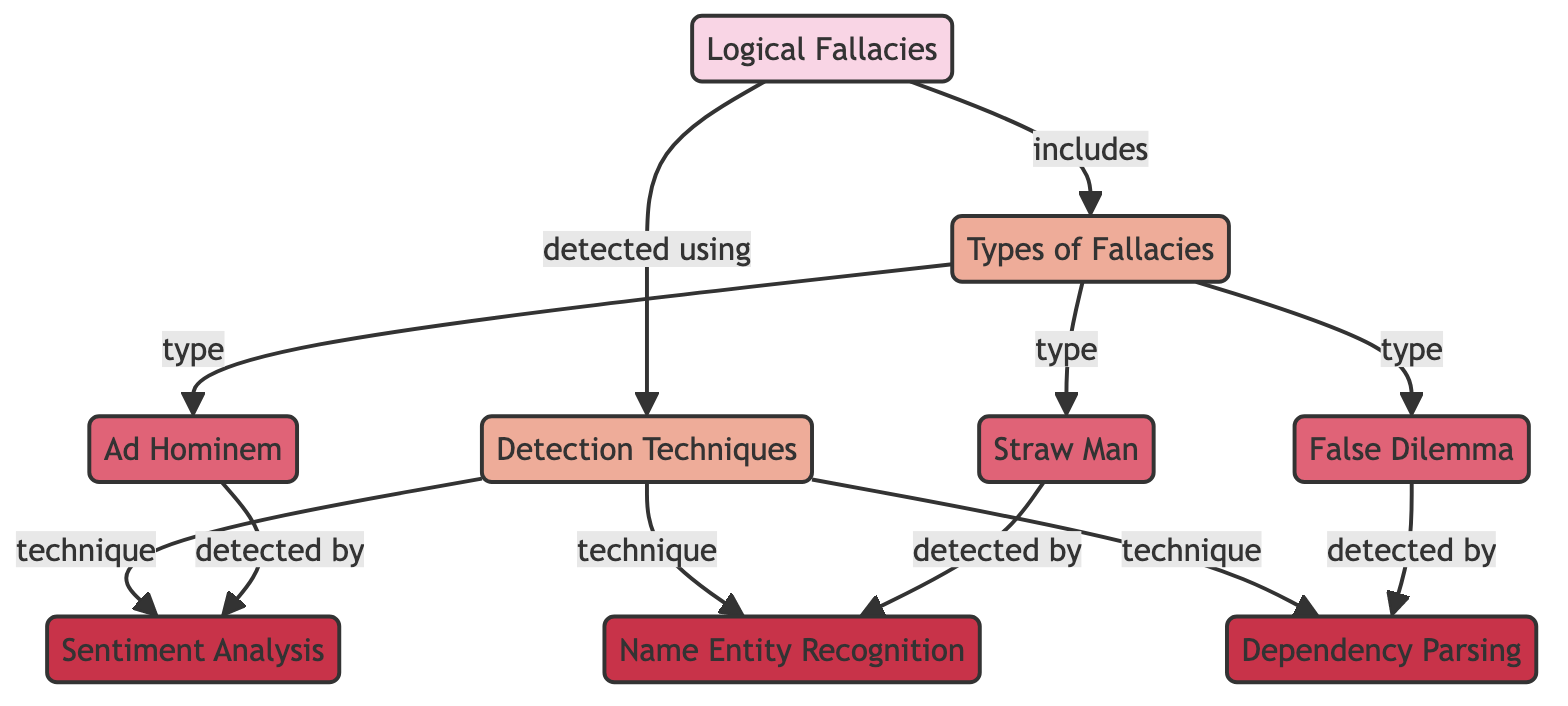What are the three types of fallacies mentioned? The diagram identifies three specific types of fallacies: Ad Hominem, Straw Man, and False Dilemma. Each of these falls under the category of "Types of Fallacies."
Answer: Ad Hominem, Straw Man, False Dilemma Which detection technique is associated with Ad Hominem? According to the diagram, Ad Hominem is detected using Sentiment Analysis, as indicated by the direct link connecting the two.
Answer: Sentiment Analysis How many detection techniques are shown in the diagram? The diagram shows three distinct detection techniques: Sentiment Analysis, Name Entity Recognition, and Dependency Parsing. By counting the nodes under "Detection Techniques," we find this total.
Answer: Three What relationship exists between Types of Fallacies and Logical Fallacies? The relationship represented in the diagram states that Types of Fallacies are included in Logical Fallacies, highlighting that Types of Fallacies are a subset of the broader category.
Answer: Includes Which type of fallacy is detected by Name Entity Recognition? The diagram indicates that the Straw Man fallacy is detected by Name Entity Recognition, providing a direct relationship between this type of fallacy and the detection technique.
Answer: Straw Man How many types of fallacies are there in total? The diagram illustrates that there are three types of fallacies listed under "Types of Fallacies." Therefore, we can deduce that the total number is three.
Answer: Three What is the connection between False Dilemma and Dependency Parsing? The diagram illustrates that False Dilemma is detected by Dependency Parsing, showing a direct link that indicates how this specific fallacy is identified.
Answer: Detected by Which detection technique appears last in the diagram? In the diagram, Dependency Parsing is positioned at the bottom of the "Detection Techniques" section, making it the last technique displayed in this category.
Answer: Dependency Parsing 